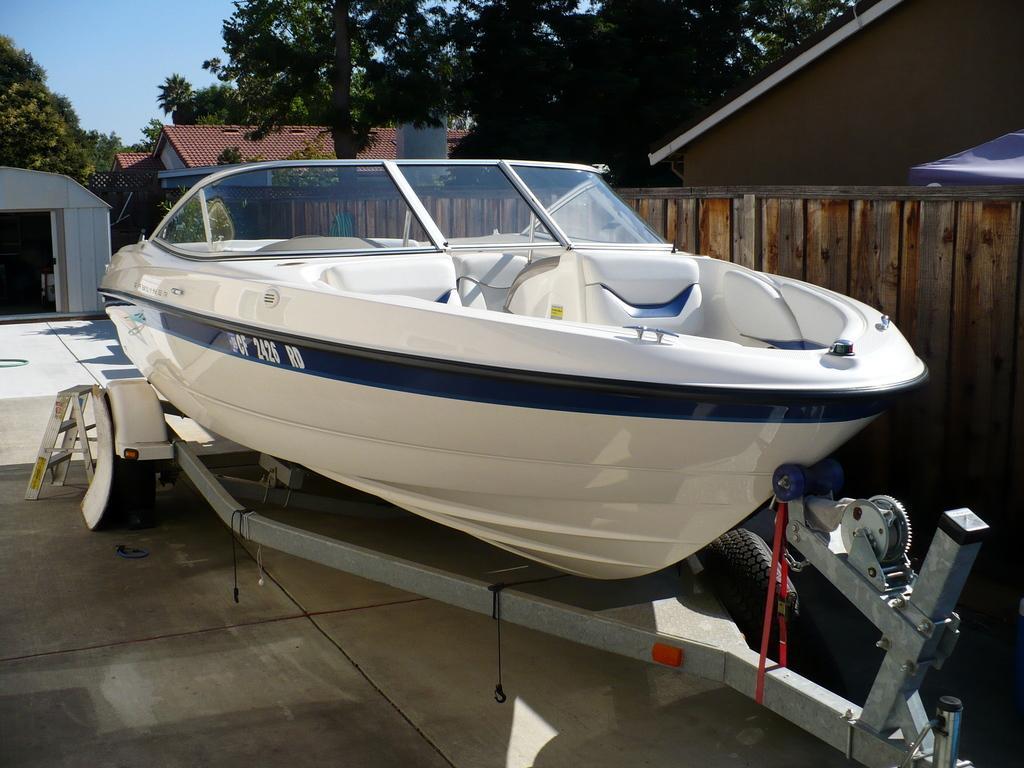Please provide a concise description of this image. In this image we can see a boat. In the background of the image there are houses, trees. There is a wooden fencing. At the bottom of the image there is floor. 